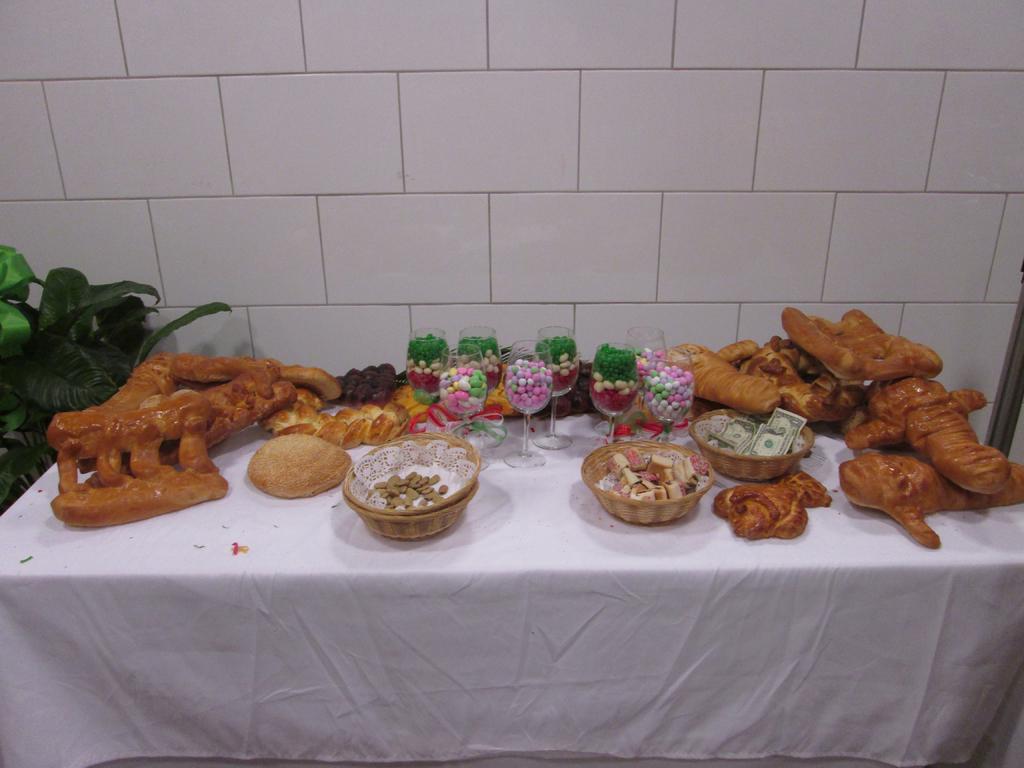Can you describe this image briefly? In this picture there is a table at the bottom side of the image, on which there are food items, money,, and there are thermocol balls in the glasses and there is a plant on the left side of the image. 